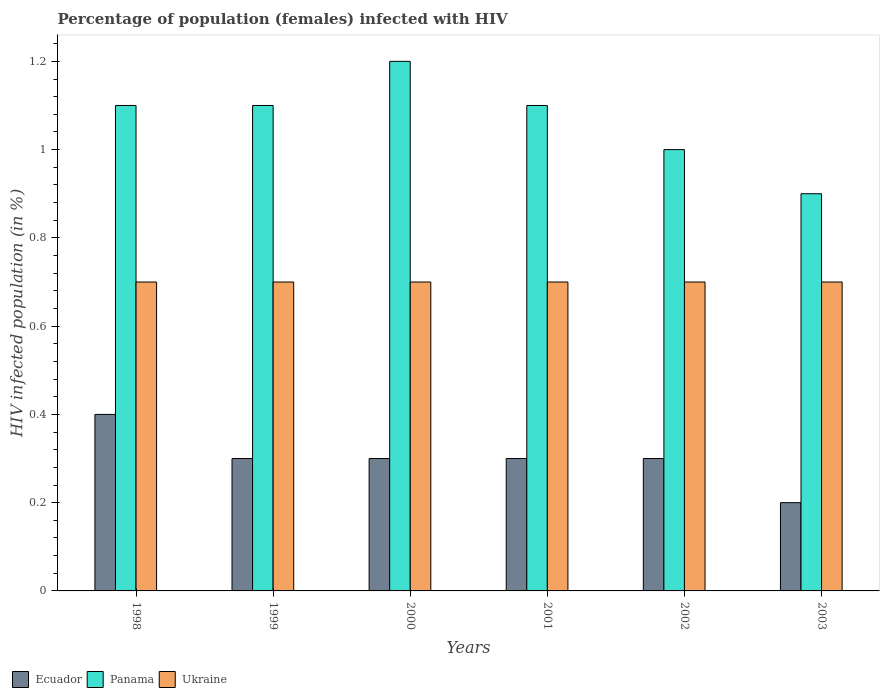How many bars are there on the 3rd tick from the left?
Your answer should be very brief. 3. In how many cases, is the number of bars for a given year not equal to the number of legend labels?
Keep it short and to the point. 0. What is the difference between the percentage of HIV infected female population in Ecuador in 1998 and that in 1999?
Provide a short and direct response. 0.1. What is the difference between the percentage of HIV infected female population in Ecuador in 1998 and the percentage of HIV infected female population in Ukraine in 1999?
Your answer should be compact. -0.3. What is the average percentage of HIV infected female population in Ukraine per year?
Make the answer very short. 0.7. In the year 2000, what is the difference between the percentage of HIV infected female population in Ecuador and percentage of HIV infected female population in Panama?
Keep it short and to the point. -0.9. What is the ratio of the percentage of HIV infected female population in Panama in 1998 to that in 2001?
Make the answer very short. 1. Is the difference between the percentage of HIV infected female population in Ecuador in 2001 and 2002 greater than the difference between the percentage of HIV infected female population in Panama in 2001 and 2002?
Offer a terse response. No. What is the difference between the highest and the second highest percentage of HIV infected female population in Panama?
Your answer should be compact. 0.1. What is the difference between the highest and the lowest percentage of HIV infected female population in Ecuador?
Provide a short and direct response. 0.2. In how many years, is the percentage of HIV infected female population in Panama greater than the average percentage of HIV infected female population in Panama taken over all years?
Ensure brevity in your answer.  4. Is the sum of the percentage of HIV infected female population in Panama in 1998 and 2000 greater than the maximum percentage of HIV infected female population in Ecuador across all years?
Your answer should be compact. Yes. What does the 3rd bar from the left in 2003 represents?
Make the answer very short. Ukraine. What does the 1st bar from the right in 2000 represents?
Your answer should be compact. Ukraine. How many bars are there?
Your response must be concise. 18. How many years are there in the graph?
Give a very brief answer. 6. What is the difference between two consecutive major ticks on the Y-axis?
Make the answer very short. 0.2. Are the values on the major ticks of Y-axis written in scientific E-notation?
Ensure brevity in your answer.  No. Where does the legend appear in the graph?
Provide a succinct answer. Bottom left. What is the title of the graph?
Keep it short and to the point. Percentage of population (females) infected with HIV. What is the label or title of the Y-axis?
Offer a terse response. HIV infected population (in %). What is the HIV infected population (in %) of Ukraine in 1998?
Your response must be concise. 0.7. What is the HIV infected population (in %) in Ecuador in 1999?
Give a very brief answer. 0.3. What is the HIV infected population (in %) of Ukraine in 1999?
Offer a terse response. 0.7. What is the HIV infected population (in %) of Ecuador in 2000?
Keep it short and to the point. 0.3. What is the HIV infected population (in %) in Ecuador in 2001?
Make the answer very short. 0.3. What is the HIV infected population (in %) in Panama in 2002?
Keep it short and to the point. 1. What is the HIV infected population (in %) of Ukraine in 2002?
Provide a short and direct response. 0.7. What is the HIV infected population (in %) of Ecuador in 2003?
Ensure brevity in your answer.  0.2. What is the HIV infected population (in %) of Panama in 2003?
Give a very brief answer. 0.9. Across all years, what is the maximum HIV infected population (in %) of Panama?
Make the answer very short. 1.2. Across all years, what is the minimum HIV infected population (in %) of Ecuador?
Your answer should be compact. 0.2. Across all years, what is the minimum HIV infected population (in %) in Panama?
Your answer should be compact. 0.9. Across all years, what is the minimum HIV infected population (in %) in Ukraine?
Offer a very short reply. 0.7. What is the total HIV infected population (in %) in Panama in the graph?
Give a very brief answer. 6.4. What is the total HIV infected population (in %) of Ukraine in the graph?
Make the answer very short. 4.2. What is the difference between the HIV infected population (in %) in Ecuador in 1998 and that in 2000?
Provide a succinct answer. 0.1. What is the difference between the HIV infected population (in %) in Panama in 1998 and that in 2000?
Provide a short and direct response. -0.1. What is the difference between the HIV infected population (in %) in Ukraine in 1998 and that in 2001?
Provide a succinct answer. 0. What is the difference between the HIV infected population (in %) in Ecuador in 1998 and that in 2003?
Ensure brevity in your answer.  0.2. What is the difference between the HIV infected population (in %) in Panama in 1998 and that in 2003?
Your answer should be compact. 0.2. What is the difference between the HIV infected population (in %) of Ukraine in 1998 and that in 2003?
Provide a short and direct response. 0. What is the difference between the HIV infected population (in %) of Ecuador in 1999 and that in 2000?
Your answer should be very brief. 0. What is the difference between the HIV infected population (in %) in Panama in 1999 and that in 2000?
Give a very brief answer. -0.1. What is the difference between the HIV infected population (in %) in Ukraine in 1999 and that in 2000?
Ensure brevity in your answer.  0. What is the difference between the HIV infected population (in %) in Panama in 1999 and that in 2001?
Offer a terse response. 0. What is the difference between the HIV infected population (in %) in Panama in 1999 and that in 2002?
Your response must be concise. 0.1. What is the difference between the HIV infected population (in %) in Ukraine in 1999 and that in 2002?
Your answer should be compact. 0. What is the difference between the HIV infected population (in %) of Ukraine in 2000 and that in 2001?
Your response must be concise. 0. What is the difference between the HIV infected population (in %) of Ecuador in 2000 and that in 2002?
Offer a terse response. 0. What is the difference between the HIV infected population (in %) of Panama in 2000 and that in 2002?
Your response must be concise. 0.2. What is the difference between the HIV infected population (in %) of Ecuador in 2001 and that in 2003?
Ensure brevity in your answer.  0.1. What is the difference between the HIV infected population (in %) in Panama in 2001 and that in 2003?
Make the answer very short. 0.2. What is the difference between the HIV infected population (in %) of Ecuador in 2002 and that in 2003?
Offer a terse response. 0.1. What is the difference between the HIV infected population (in %) of Panama in 2002 and that in 2003?
Ensure brevity in your answer.  0.1. What is the difference between the HIV infected population (in %) of Ukraine in 2002 and that in 2003?
Provide a short and direct response. 0. What is the difference between the HIV infected population (in %) of Ecuador in 1998 and the HIV infected population (in %) of Ukraine in 1999?
Your response must be concise. -0.3. What is the difference between the HIV infected population (in %) in Panama in 1998 and the HIV infected population (in %) in Ukraine in 2000?
Your answer should be very brief. 0.4. What is the difference between the HIV infected population (in %) of Ecuador in 1998 and the HIV infected population (in %) of Panama in 2001?
Offer a terse response. -0.7. What is the difference between the HIV infected population (in %) of Panama in 1998 and the HIV infected population (in %) of Ukraine in 2001?
Your response must be concise. 0.4. What is the difference between the HIV infected population (in %) in Ecuador in 1998 and the HIV infected population (in %) in Panama in 2002?
Your answer should be very brief. -0.6. What is the difference between the HIV infected population (in %) of Ecuador in 1998 and the HIV infected population (in %) of Ukraine in 2003?
Provide a short and direct response. -0.3. What is the difference between the HIV infected population (in %) of Panama in 1998 and the HIV infected population (in %) of Ukraine in 2003?
Keep it short and to the point. 0.4. What is the difference between the HIV infected population (in %) in Ecuador in 1999 and the HIV infected population (in %) in Panama in 2000?
Make the answer very short. -0.9. What is the difference between the HIV infected population (in %) of Ecuador in 1999 and the HIV infected population (in %) of Ukraine in 2000?
Offer a very short reply. -0.4. What is the difference between the HIV infected population (in %) of Ecuador in 1999 and the HIV infected population (in %) of Ukraine in 2002?
Give a very brief answer. -0.4. What is the difference between the HIV infected population (in %) in Ecuador in 1999 and the HIV infected population (in %) in Panama in 2003?
Your answer should be compact. -0.6. What is the difference between the HIV infected population (in %) of Ecuador in 1999 and the HIV infected population (in %) of Ukraine in 2003?
Ensure brevity in your answer.  -0.4. What is the difference between the HIV infected population (in %) in Ecuador in 2000 and the HIV infected population (in %) in Panama in 2001?
Keep it short and to the point. -0.8. What is the difference between the HIV infected population (in %) of Ecuador in 2000 and the HIV infected population (in %) of Ukraine in 2002?
Offer a terse response. -0.4. What is the difference between the HIV infected population (in %) of Panama in 2000 and the HIV infected population (in %) of Ukraine in 2002?
Make the answer very short. 0.5. What is the difference between the HIV infected population (in %) of Panama in 2000 and the HIV infected population (in %) of Ukraine in 2003?
Provide a succinct answer. 0.5. What is the difference between the HIV infected population (in %) in Panama in 2001 and the HIV infected population (in %) in Ukraine in 2002?
Provide a short and direct response. 0.4. What is the difference between the HIV infected population (in %) of Ecuador in 2001 and the HIV infected population (in %) of Ukraine in 2003?
Your answer should be very brief. -0.4. What is the difference between the HIV infected population (in %) in Panama in 2001 and the HIV infected population (in %) in Ukraine in 2003?
Your answer should be compact. 0.4. What is the average HIV infected population (in %) in Panama per year?
Keep it short and to the point. 1.07. In the year 1998, what is the difference between the HIV infected population (in %) of Ecuador and HIV infected population (in %) of Ukraine?
Offer a terse response. -0.3. In the year 1998, what is the difference between the HIV infected population (in %) in Panama and HIV infected population (in %) in Ukraine?
Offer a very short reply. 0.4. In the year 1999, what is the difference between the HIV infected population (in %) in Ecuador and HIV infected population (in %) in Panama?
Your answer should be compact. -0.8. In the year 1999, what is the difference between the HIV infected population (in %) of Ecuador and HIV infected population (in %) of Ukraine?
Ensure brevity in your answer.  -0.4. In the year 2000, what is the difference between the HIV infected population (in %) of Ecuador and HIV infected population (in %) of Panama?
Ensure brevity in your answer.  -0.9. In the year 2000, what is the difference between the HIV infected population (in %) in Panama and HIV infected population (in %) in Ukraine?
Give a very brief answer. 0.5. In the year 2001, what is the difference between the HIV infected population (in %) of Ecuador and HIV infected population (in %) of Panama?
Give a very brief answer. -0.8. In the year 2001, what is the difference between the HIV infected population (in %) of Ecuador and HIV infected population (in %) of Ukraine?
Keep it short and to the point. -0.4. In the year 2001, what is the difference between the HIV infected population (in %) of Panama and HIV infected population (in %) of Ukraine?
Give a very brief answer. 0.4. In the year 2002, what is the difference between the HIV infected population (in %) in Panama and HIV infected population (in %) in Ukraine?
Offer a terse response. 0.3. In the year 2003, what is the difference between the HIV infected population (in %) in Ecuador and HIV infected population (in %) in Ukraine?
Keep it short and to the point. -0.5. In the year 2003, what is the difference between the HIV infected population (in %) of Panama and HIV infected population (in %) of Ukraine?
Your response must be concise. 0.2. What is the ratio of the HIV infected population (in %) in Ecuador in 1998 to that in 1999?
Keep it short and to the point. 1.33. What is the ratio of the HIV infected population (in %) in Panama in 1998 to that in 2000?
Keep it short and to the point. 0.92. What is the ratio of the HIV infected population (in %) in Ukraine in 1998 to that in 2000?
Provide a short and direct response. 1. What is the ratio of the HIV infected population (in %) in Ecuador in 1998 to that in 2002?
Make the answer very short. 1.33. What is the ratio of the HIV infected population (in %) of Panama in 1998 to that in 2002?
Provide a short and direct response. 1.1. What is the ratio of the HIV infected population (in %) in Ukraine in 1998 to that in 2002?
Ensure brevity in your answer.  1. What is the ratio of the HIV infected population (in %) of Panama in 1998 to that in 2003?
Your answer should be very brief. 1.22. What is the ratio of the HIV infected population (in %) in Panama in 1999 to that in 2000?
Ensure brevity in your answer.  0.92. What is the ratio of the HIV infected population (in %) of Panama in 1999 to that in 2001?
Make the answer very short. 1. What is the ratio of the HIV infected population (in %) in Ecuador in 1999 to that in 2002?
Provide a short and direct response. 1. What is the ratio of the HIV infected population (in %) in Ukraine in 1999 to that in 2002?
Offer a terse response. 1. What is the ratio of the HIV infected population (in %) of Panama in 1999 to that in 2003?
Your answer should be very brief. 1.22. What is the ratio of the HIV infected population (in %) in Ukraine in 1999 to that in 2003?
Provide a short and direct response. 1. What is the ratio of the HIV infected population (in %) of Panama in 2000 to that in 2001?
Offer a terse response. 1.09. What is the ratio of the HIV infected population (in %) of Ukraine in 2000 to that in 2001?
Your answer should be very brief. 1. What is the ratio of the HIV infected population (in %) of Ecuador in 2000 to that in 2002?
Give a very brief answer. 1. What is the ratio of the HIV infected population (in %) in Panama in 2000 to that in 2002?
Give a very brief answer. 1.2. What is the ratio of the HIV infected population (in %) in Ukraine in 2000 to that in 2002?
Give a very brief answer. 1. What is the ratio of the HIV infected population (in %) in Ukraine in 2000 to that in 2003?
Your answer should be compact. 1. What is the ratio of the HIV infected population (in %) in Panama in 2001 to that in 2002?
Ensure brevity in your answer.  1.1. What is the ratio of the HIV infected population (in %) in Panama in 2001 to that in 2003?
Ensure brevity in your answer.  1.22. What is the ratio of the HIV infected population (in %) in Ukraine in 2001 to that in 2003?
Ensure brevity in your answer.  1. What is the ratio of the HIV infected population (in %) of Ecuador in 2002 to that in 2003?
Your response must be concise. 1.5. What is the ratio of the HIV infected population (in %) of Ukraine in 2002 to that in 2003?
Offer a terse response. 1. What is the difference between the highest and the lowest HIV infected population (in %) in Ecuador?
Give a very brief answer. 0.2. What is the difference between the highest and the lowest HIV infected population (in %) of Panama?
Your answer should be very brief. 0.3. 